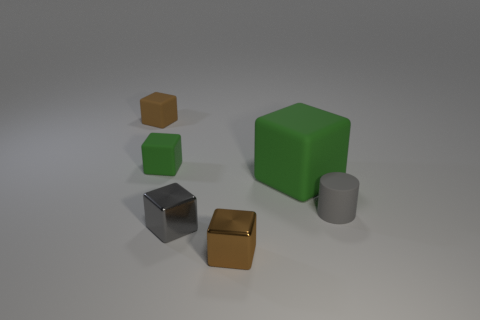Subtract all green cubes. How many cubes are left? 3 Subtract 3 cubes. How many cubes are left? 2 Add 2 small brown things. How many objects exist? 8 Subtract 0 red cylinders. How many objects are left? 6 Subtract all cubes. How many objects are left? 1 Subtract all yellow cubes. Subtract all green cylinders. How many cubes are left? 5 Subtract all yellow cylinders. How many gray blocks are left? 1 Subtract all small yellow balls. Subtract all tiny rubber objects. How many objects are left? 3 Add 1 tiny blocks. How many tiny blocks are left? 5 Add 4 large green blocks. How many large green blocks exist? 5 